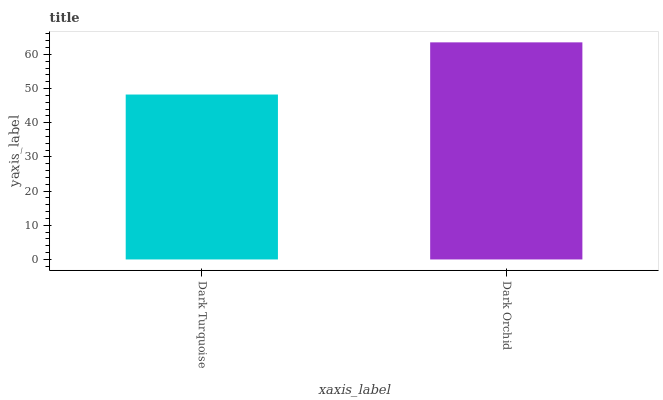Is Dark Orchid the minimum?
Answer yes or no. No. Is Dark Orchid greater than Dark Turquoise?
Answer yes or no. Yes. Is Dark Turquoise less than Dark Orchid?
Answer yes or no. Yes. Is Dark Turquoise greater than Dark Orchid?
Answer yes or no. No. Is Dark Orchid less than Dark Turquoise?
Answer yes or no. No. Is Dark Orchid the high median?
Answer yes or no. Yes. Is Dark Turquoise the low median?
Answer yes or no. Yes. Is Dark Turquoise the high median?
Answer yes or no. No. Is Dark Orchid the low median?
Answer yes or no. No. 